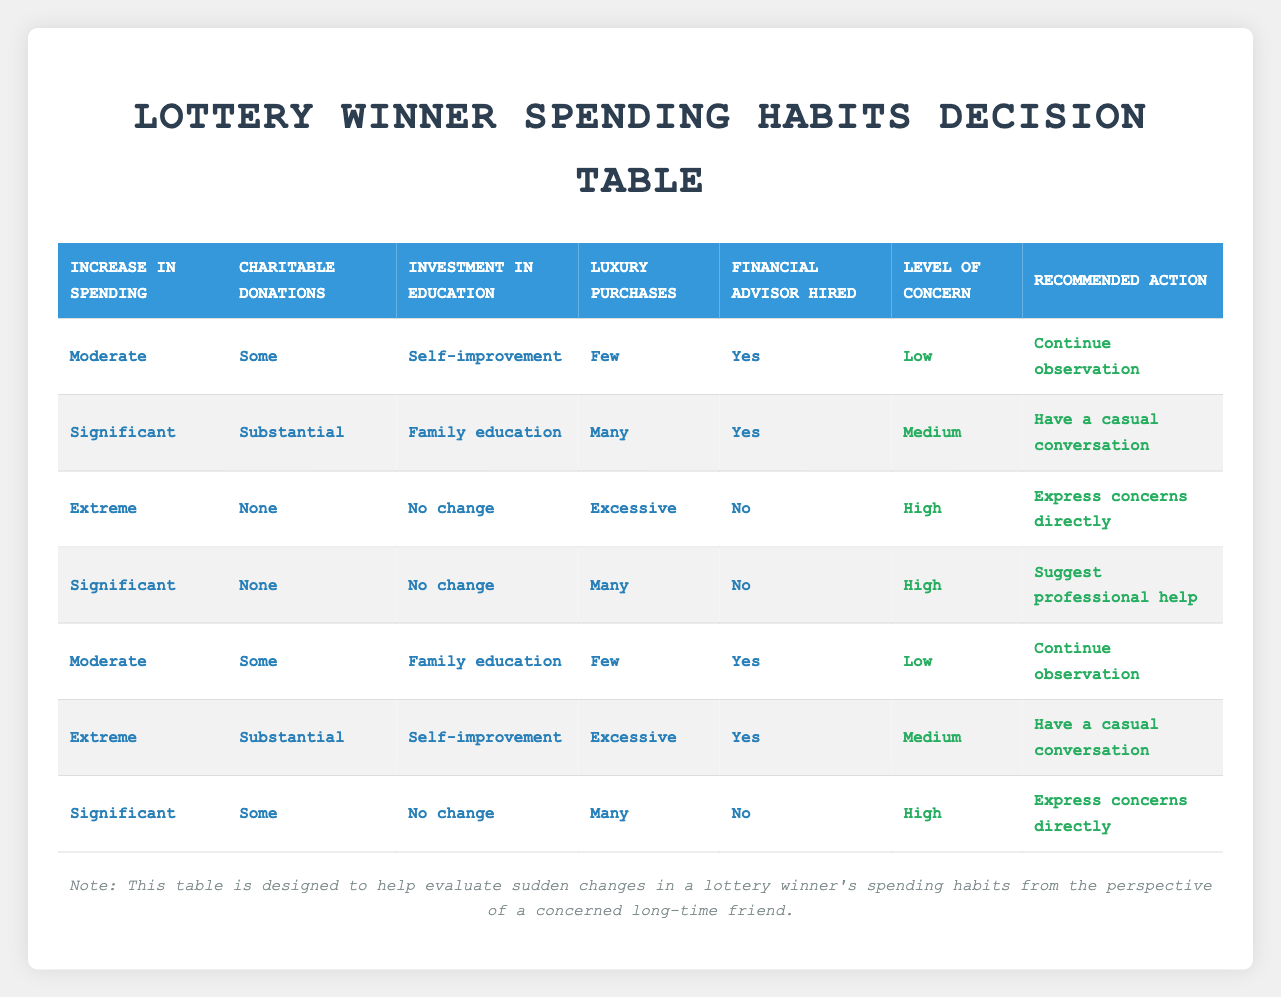What is the level of concern when the increase in spending is significant, charitable donations are substantial, and a financial advisor is hired? From the table, we locate the entry where "increase in spending" is "Significant", "charitable donations" is "Substantial", and "financial advisor hired" is "Yes". This corresponds to the second row, which indicates a "Medium" level of concern.
Answer: Medium In how many cases is the recommended action to "Express concerns directly"? We look down the "Recommended action" column. The rows where "Express concerns directly" is noted are the third, fourth, and sixth entries. Thus, there are three cases in total.
Answer: 3 Is there any instance where luxury purchases are excessive while hiring a financial advisor is not an option? Referencing the table, we find that in the third row, luxury purchases are "Excessive" and a financial advisor is "No", making it a true condition.
Answer: Yes What is the minimum level of concern for a lottery winner who makes significant charitable donations and has hired a financial advisor? In this case, we check the rows where "charitable donations" is "Substantial" and "financial advisor hired" is "Yes". The minimum level of concern seen in the table is found in the second entry; it is "Medium".
Answer: Medium How many combinations in the table result in a high level of concern? To find this, we examine the table for entries where the "Level of concern" is "High". Rows three, four, and sixth provide "High" concern. Thus, there are three combinations that result in this level.
Answer: 3 What is the recommended action when spending increases moderately and luxury purchases are few with a financial advisor hired? We reference the first row where "increase in spending" is "Moderate", "luxury purchases" is "Few", and "financial advisor hired" is "Yes". The corresponding action is to "Continue observation".
Answer: Continue observation Under what conditions would a lottery winner be recommended to suggest professional help? Looking for instances where "Recommended action" is "Suggest professional help", we find it in the fourth entry where "Increase in spending" is "Significant", "Charitable donations" is "None", and no change is indicated for education. These specific conditions lead to the recommendation.
Answer: Significant, None, No change How would the level of concern change if luxury purchases increased from few to many while charitable donations remained the same? This question requires a logical comparison. The first scenario results in "Low" concern (row one), while an increase to many luxury purchases with no change in charitable donations would yield "High" concern if spending is significant. It indicates that concern would escalate from low to high.
Answer: Increase from low to high 